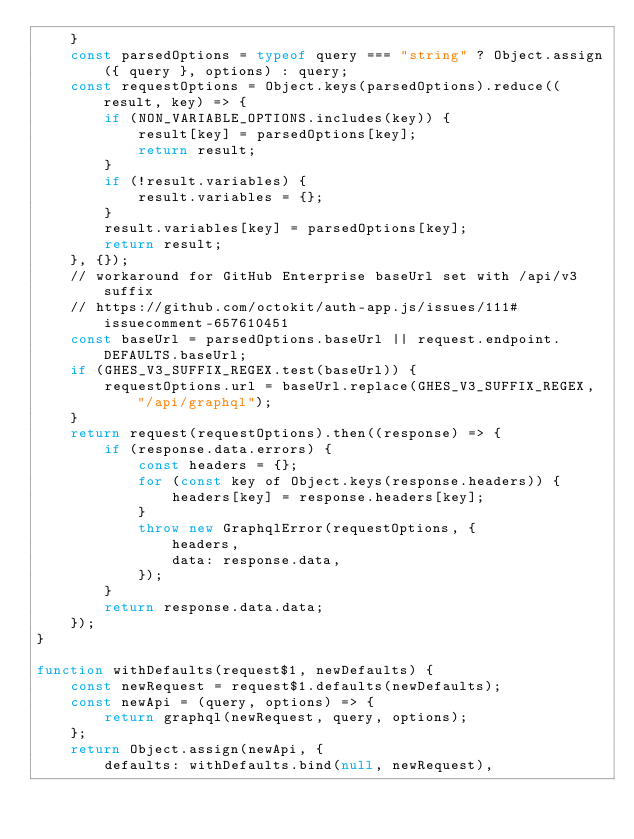<code> <loc_0><loc_0><loc_500><loc_500><_JavaScript_>    }
    const parsedOptions = typeof query === "string" ? Object.assign({ query }, options) : query;
    const requestOptions = Object.keys(parsedOptions).reduce((result, key) => {
        if (NON_VARIABLE_OPTIONS.includes(key)) {
            result[key] = parsedOptions[key];
            return result;
        }
        if (!result.variables) {
            result.variables = {};
        }
        result.variables[key] = parsedOptions[key];
        return result;
    }, {});
    // workaround for GitHub Enterprise baseUrl set with /api/v3 suffix
    // https://github.com/octokit/auth-app.js/issues/111#issuecomment-657610451
    const baseUrl = parsedOptions.baseUrl || request.endpoint.DEFAULTS.baseUrl;
    if (GHES_V3_SUFFIX_REGEX.test(baseUrl)) {
        requestOptions.url = baseUrl.replace(GHES_V3_SUFFIX_REGEX, "/api/graphql");
    }
    return request(requestOptions).then((response) => {
        if (response.data.errors) {
            const headers = {};
            for (const key of Object.keys(response.headers)) {
                headers[key] = response.headers[key];
            }
            throw new GraphqlError(requestOptions, {
                headers,
                data: response.data,
            });
        }
        return response.data.data;
    });
}

function withDefaults(request$1, newDefaults) {
    const newRequest = request$1.defaults(newDefaults);
    const newApi = (query, options) => {
        return graphql(newRequest, query, options);
    };
    return Object.assign(newApi, {
        defaults: withDefaults.bind(null, newRequest),</code> 